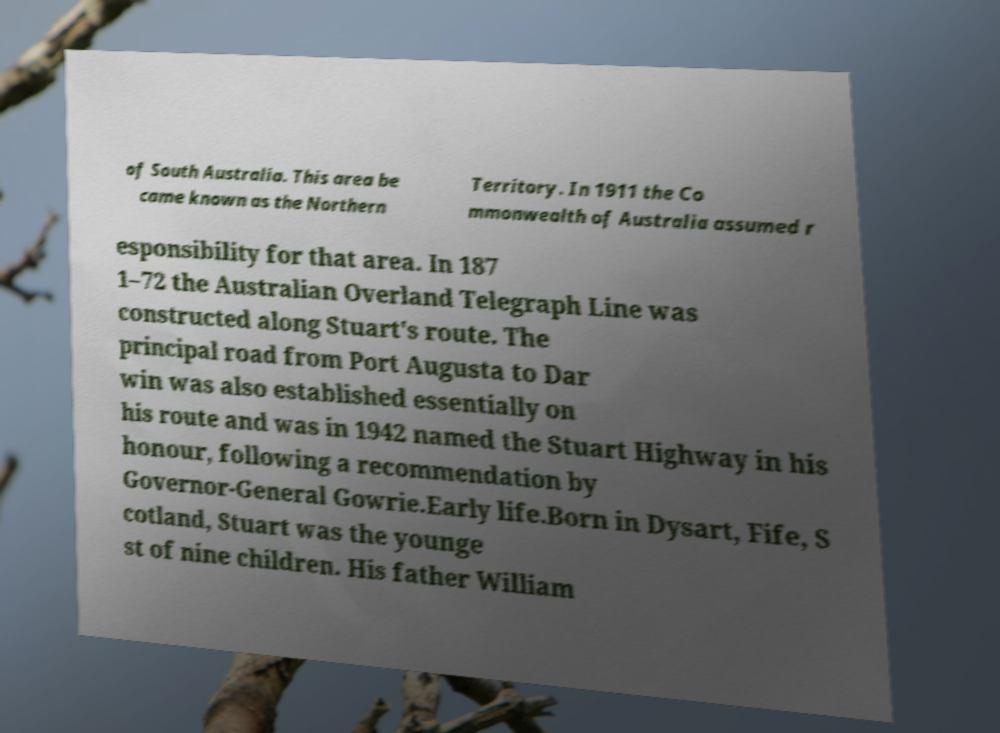Can you read and provide the text displayed in the image?This photo seems to have some interesting text. Can you extract and type it out for me? of South Australia. This area be came known as the Northern Territory. In 1911 the Co mmonwealth of Australia assumed r esponsibility for that area. In 187 1–72 the Australian Overland Telegraph Line was constructed along Stuart's route. The principal road from Port Augusta to Dar win was also established essentially on his route and was in 1942 named the Stuart Highway in his honour, following a recommendation by Governor-General Gowrie.Early life.Born in Dysart, Fife, S cotland, Stuart was the younge st of nine children. His father William 